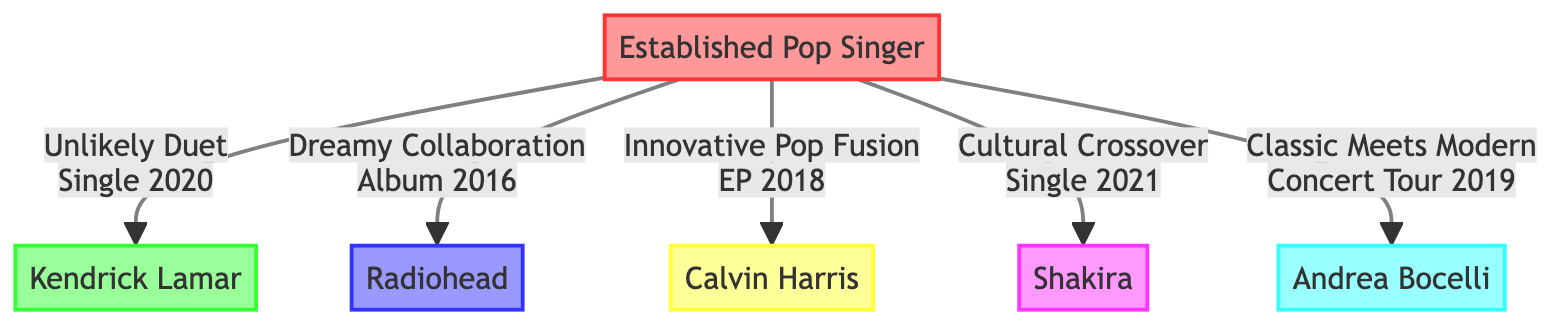What is the genre of the partner in the "Unlikely Duet"? The diagram indicates that the partner in the "Unlikely Duet" is Kendrick Lamar, who is classified as a Hip Hop artist.
Answer: Hip Hop How many collaborations did the Established Pop Singer have? Counting the collaboration entries under the Established Pop Singer in the diagram, there are a total of five collaborations listed.
Answer: 5 What type of collaboration is "Cultural Crossover"? By examining the collaboration type associated with "Cultural Crossover" in the diagram, it is identified as a "Featured Track."
Answer: Featured Track Which year was "Innovative Pop Fusion" released? The diagram specifies that the "Innovative Pop Fusion" project was released in 2018, as shown under its details.
Answer: 2018 What genre is associated with "Dreamy Collaboration"? Looking at the details, "Dreamy Collaboration" is identified in the diagram as being in the genre of Alternative Rock.
Answer: Alternative Rock What is the project type for Kendrick Lamar's collaboration? In the diagram, the project type associated with Kendrick Lamar's collaboration, "Unlikely Duet," is categorized as a "Single."
Answer: Single Who performed the "Classic Meets Modern" duet? The diagram indicates that the partner in the "Classic Meets Modern" duet is Andrea Bocelli, making him the performer associated with this collaboration.
Answer: Andrea Bocelli How many duet collaborations does the Established Pop Singer have? By counting the duet collaborations specifically—"Unlikely Duet" and "Classic Meets Modern"—from the diagram, it totals to two duet collaborations.
Answer: 2 Which collaboration is related to Latin Pop? Referring to the diagram, the collaboration titled "Cultural Crossover" is specifically noted to be associated with Latin Pop.
Answer: Cultural Crossover 